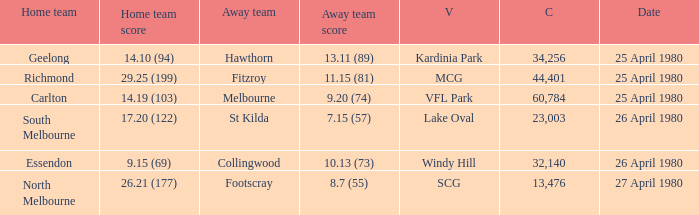What wa the date of the North Melbourne home game? 27 April 1980. 